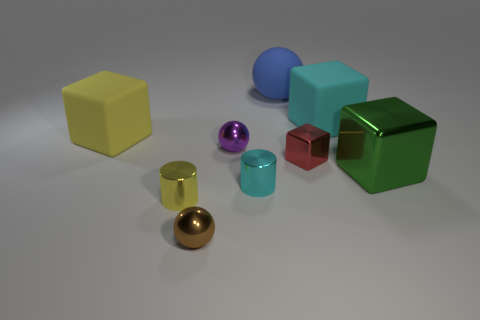Is the red cube the same size as the blue ball? Upon observation, the red cube appears to be larger in volume compared to the blue ball. The cube's edges suggest that each face is longer than the diameter of the ball, indicating a difference in size. 